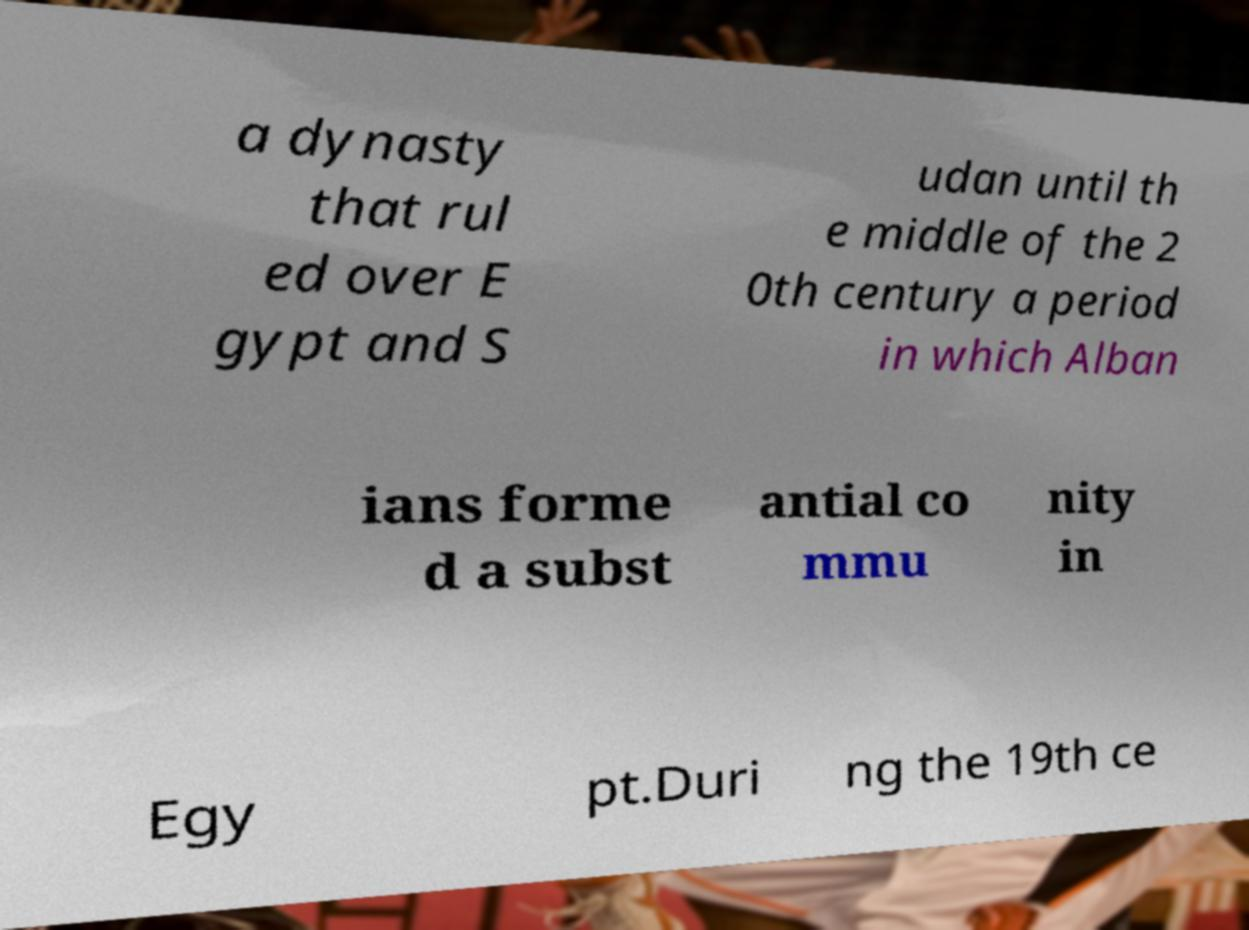Can you read and provide the text displayed in the image?This photo seems to have some interesting text. Can you extract and type it out for me? a dynasty that rul ed over E gypt and S udan until th e middle of the 2 0th century a period in which Alban ians forme d a subst antial co mmu nity in Egy pt.Duri ng the 19th ce 